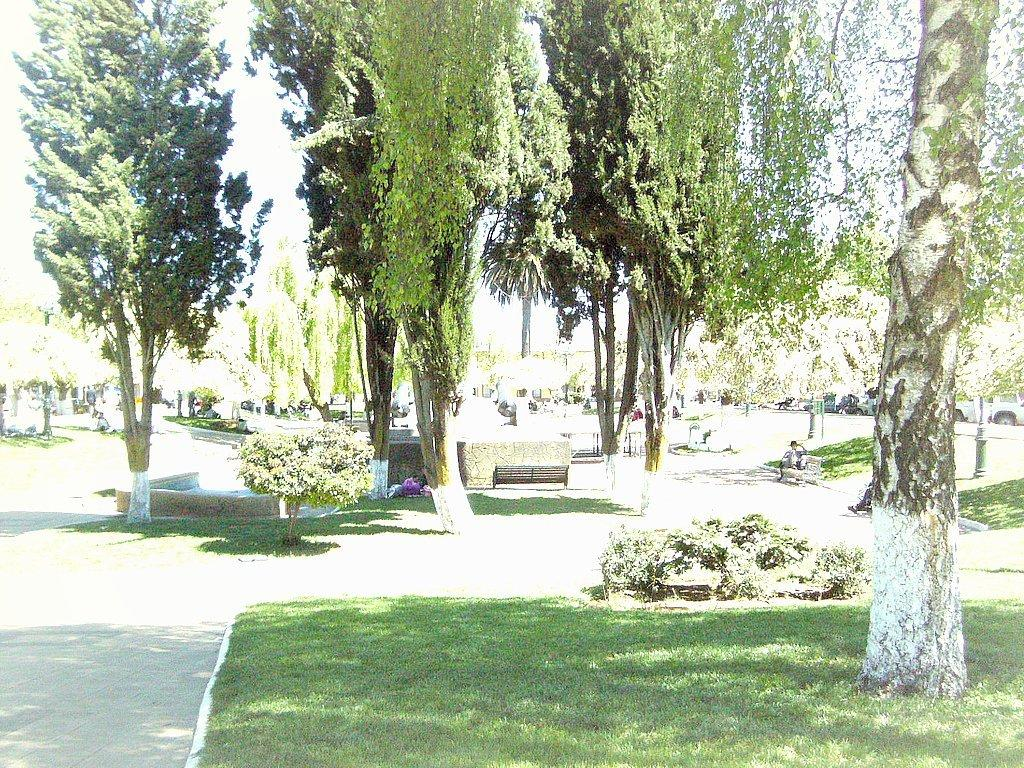What type of vegetation can be seen in the image? There are trees and grass in the image. What else is present in the image besides vegetation? There are vehicles, people, a bench, a wall, and the sky visible in the image. Can you describe the vehicles in the image? The provided facts do not specify the type or number of vehicles in the image. What is the people's location in the image? The people are in the image, but their exact location is not specified. What is the bench used for in the image? The bench might be used for sitting or resting in the image. What does the mom say to the level in the image? There is no mention of a mom or a level in the image; the provided facts only mention trees, grass, vehicles, people, a bench, a wall, and the sky. 